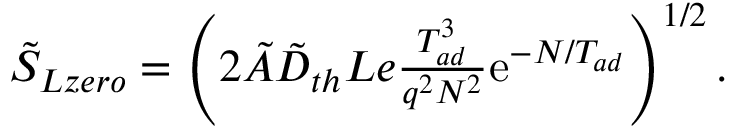Convert formula to latex. <formula><loc_0><loc_0><loc_500><loc_500>\begin{array} { r } { \tilde { S } _ { L z e r o } = \left ( 2 \tilde { A } \tilde { D } _ { t h } L e \frac { T _ { a d } ^ { 3 } } { q ^ { 2 } N ^ { 2 } } e ^ { - N / T _ { a d } } \right ) ^ { 1 / 2 } . } \end{array}</formula> 